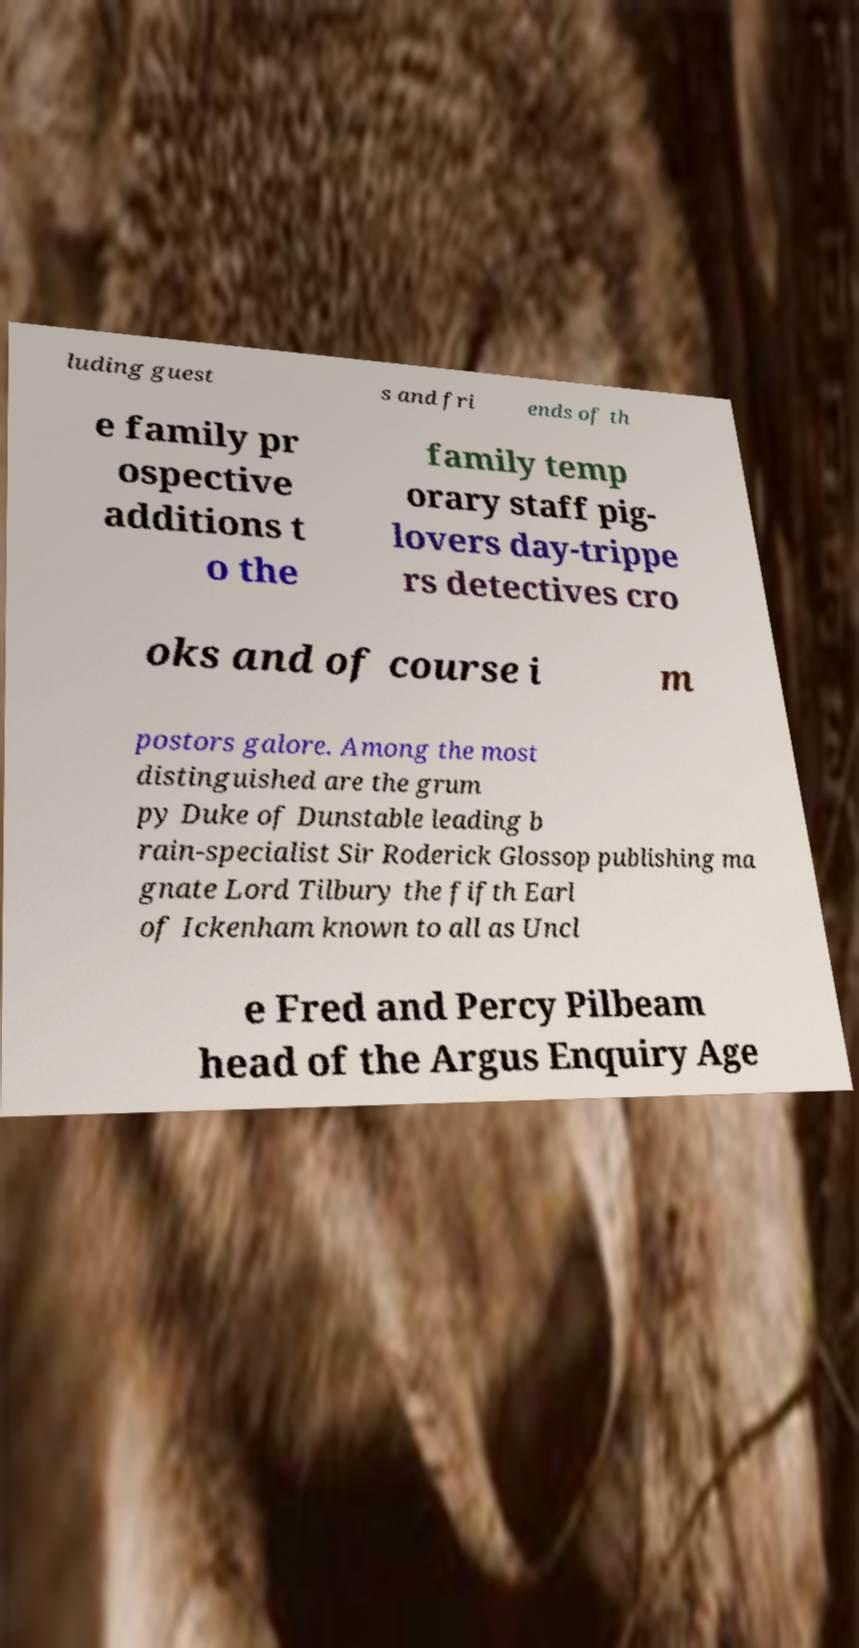For documentation purposes, I need the text within this image transcribed. Could you provide that? luding guest s and fri ends of th e family pr ospective additions t o the family temp orary staff pig- lovers day-trippe rs detectives cro oks and of course i m postors galore. Among the most distinguished are the grum py Duke of Dunstable leading b rain-specialist Sir Roderick Glossop publishing ma gnate Lord Tilbury the fifth Earl of Ickenham known to all as Uncl e Fred and Percy Pilbeam head of the Argus Enquiry Age 